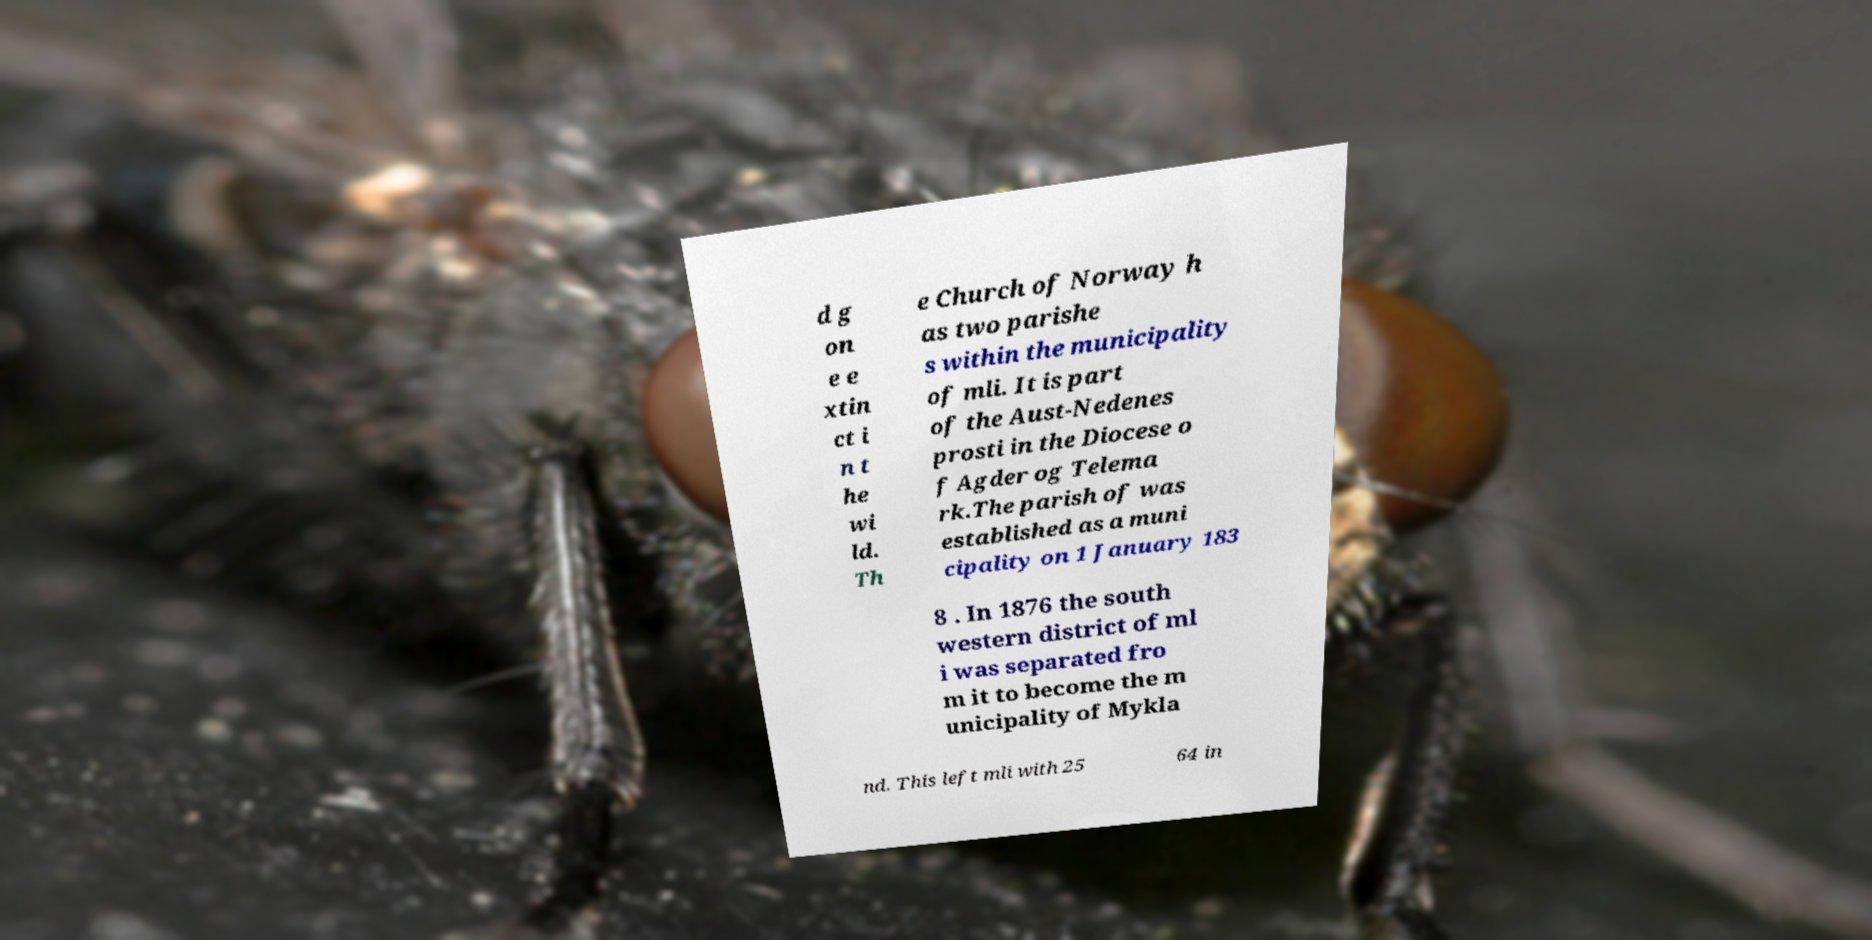Could you extract and type out the text from this image? d g on e e xtin ct i n t he wi ld. Th e Church of Norway h as two parishe s within the municipality of mli. It is part of the Aust-Nedenes prosti in the Diocese o f Agder og Telema rk.The parish of was established as a muni cipality on 1 January 183 8 . In 1876 the south western district of ml i was separated fro m it to become the m unicipality of Mykla nd. This left mli with 25 64 in 